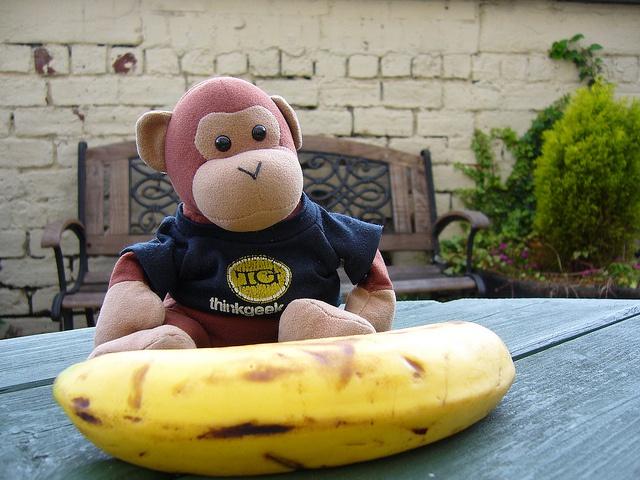Describe the objects in this image and their specific colors. I can see banana in gray, khaki, beige, and olive tones, dining table in gray, lightblue, and darkgray tones, and bench in gray, black, and darkgreen tones in this image. 